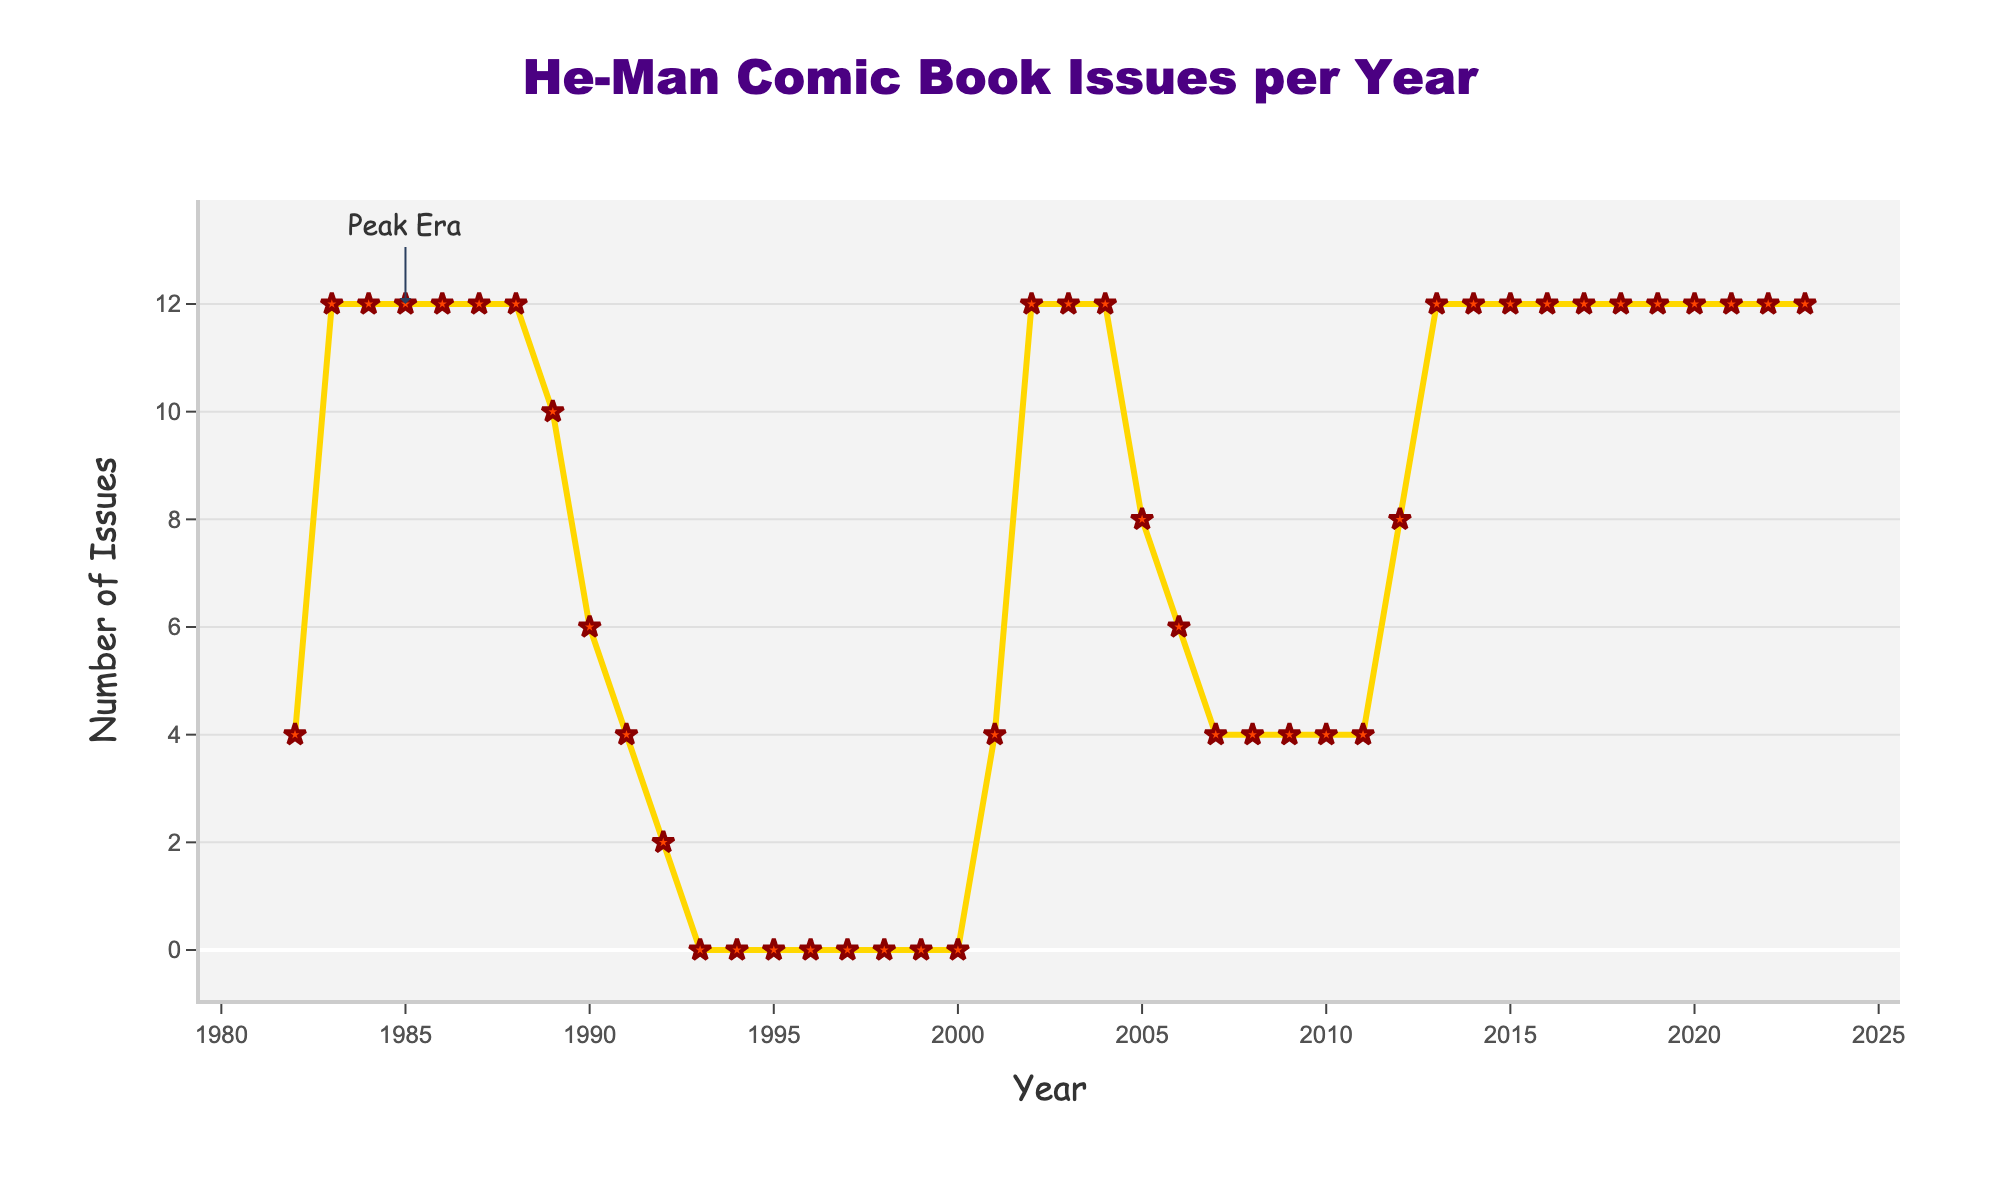How many issues were published in 1982? Look for the data point corresponding to the year 1982 on the chart.
Answer: 4 Which years had a sharp drop in the number of issues published after a period of consistency? Identify years where the number of issues significantly dropped after a consistent production.
Answer: 1989 and 1990 What is the difference in the number of issues between the peak era (1982-1987) and the early 90s (1990-1992)? Calculate the total number of issues for both periods and find the difference: Peak era: 4 + (12*5) = 64, Early 90s: 6 + 4 + 2 = 12, Difference = 64 - 12 = 52
Answer: 52 In which year did the publication of He-Man comics resume after a long break? Identify the first year after the break (period with zero issues) where comics were published again.
Answer: 2001 How many total issues were published between 2001 and 2023? Sum the number of issues published each year from 2001 to 2023.
Answer: 180 Compare the number of issues published in 1983 and 2023. Which year had more issues? Look for the data points corresponding to the years 1983 and 2023 and compare their values.
Answer: Both had the same number of issues What is the average number of issues published per year from 1982 to 1989? Calculate the sum of issues from 1982 to 1989 and divide by the number of years (8): (4 + 12 + 12 + 12 + 12 + 12 + 12 + 10)/8 = 10.75
Answer: 10.75 Describe the trend in the number of issues published from 1993 to 2000. Identify the values for the years 1993 to 2000; notice that no issues were published in this period.
Answer: Zero issues were published Was there a year when exactly 8 issues were published? If so, name the year(s). Look for data points where the number of issues is exactly 8.
Answer: 2005 and 2012 